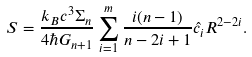Convert formula to latex. <formula><loc_0><loc_0><loc_500><loc_500>S = \frac { k _ { B } c ^ { 3 } \Sigma _ { n } } { 4 \hbar { G } _ { n + 1 } } \sum _ { i = 1 } ^ { m } \frac { i ( n - 1 ) } { n - 2 i + 1 } { \hat { c } _ { i } } R ^ { 2 - 2 i } .</formula> 